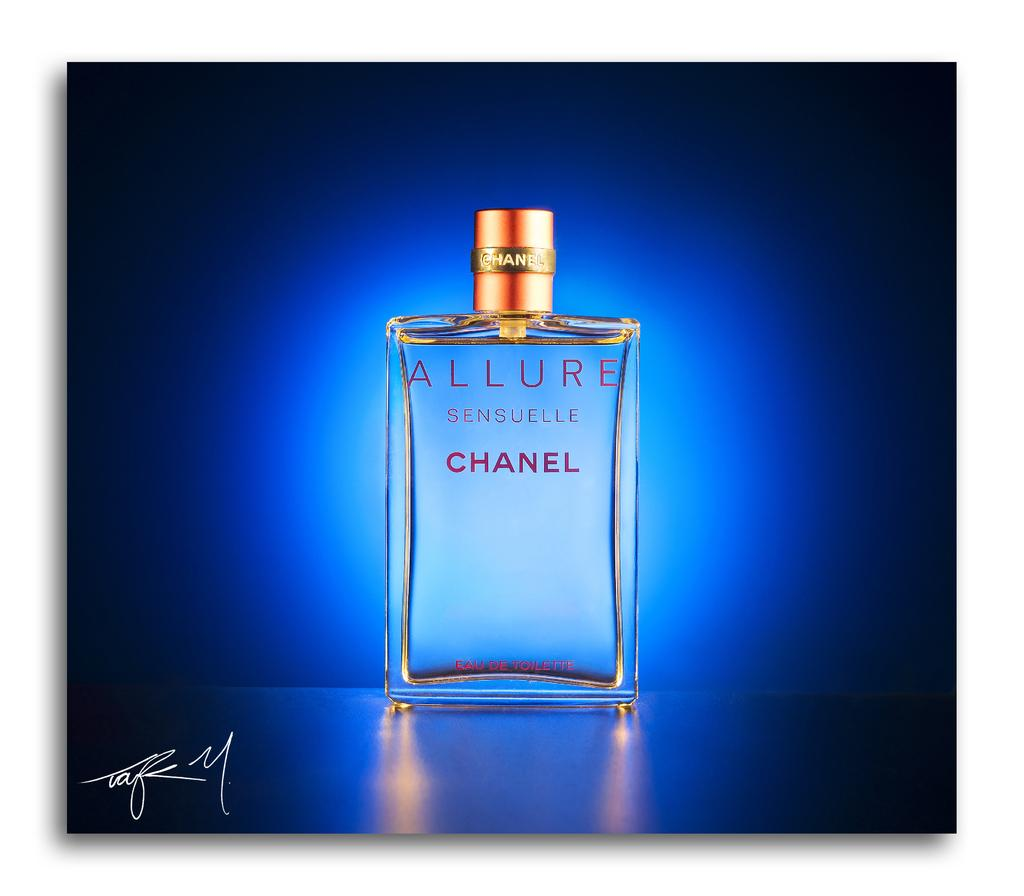<image>
Give a short and clear explanation of the subsequent image. A bottle of Allure by Chanel sits against a blue background. 